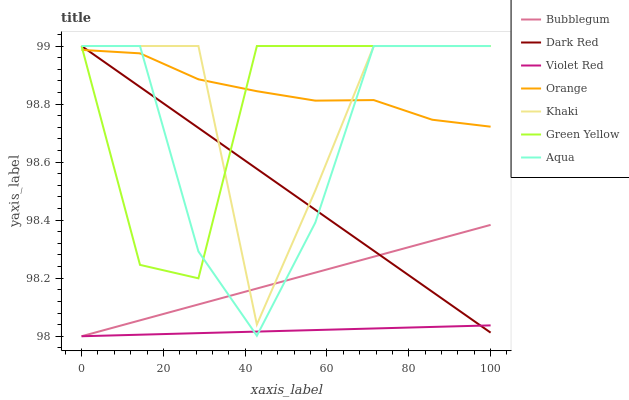Does Violet Red have the minimum area under the curve?
Answer yes or no. Yes. Does Orange have the maximum area under the curve?
Answer yes or no. Yes. Does Khaki have the minimum area under the curve?
Answer yes or no. No. Does Khaki have the maximum area under the curve?
Answer yes or no. No. Is Violet Red the smoothest?
Answer yes or no. Yes. Is Khaki the roughest?
Answer yes or no. Yes. Is Dark Red the smoothest?
Answer yes or no. No. Is Dark Red the roughest?
Answer yes or no. No. Does Violet Red have the lowest value?
Answer yes or no. Yes. Does Khaki have the lowest value?
Answer yes or no. No. Does Green Yellow have the highest value?
Answer yes or no. Yes. Does Bubblegum have the highest value?
Answer yes or no. No. Is Bubblegum less than Orange?
Answer yes or no. Yes. Is Orange greater than Bubblegum?
Answer yes or no. Yes. Does Khaki intersect Green Yellow?
Answer yes or no. Yes. Is Khaki less than Green Yellow?
Answer yes or no. No. Is Khaki greater than Green Yellow?
Answer yes or no. No. Does Bubblegum intersect Orange?
Answer yes or no. No. 